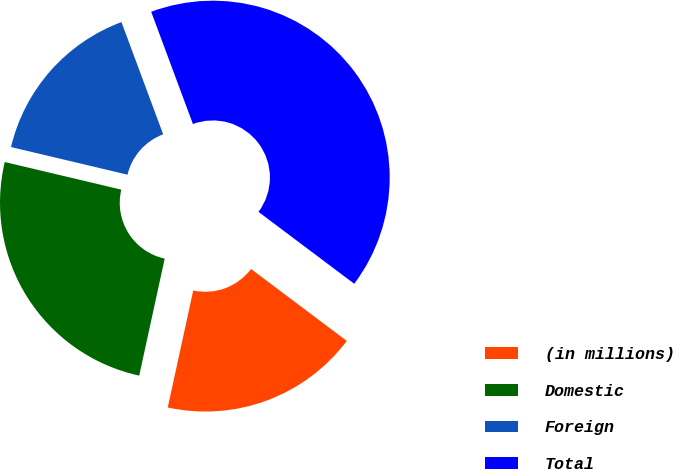Convert chart. <chart><loc_0><loc_0><loc_500><loc_500><pie_chart><fcel>(in millions)<fcel>Domestic<fcel>Foreign<fcel>Total<nl><fcel>18.16%<fcel>25.29%<fcel>15.63%<fcel>40.92%<nl></chart> 